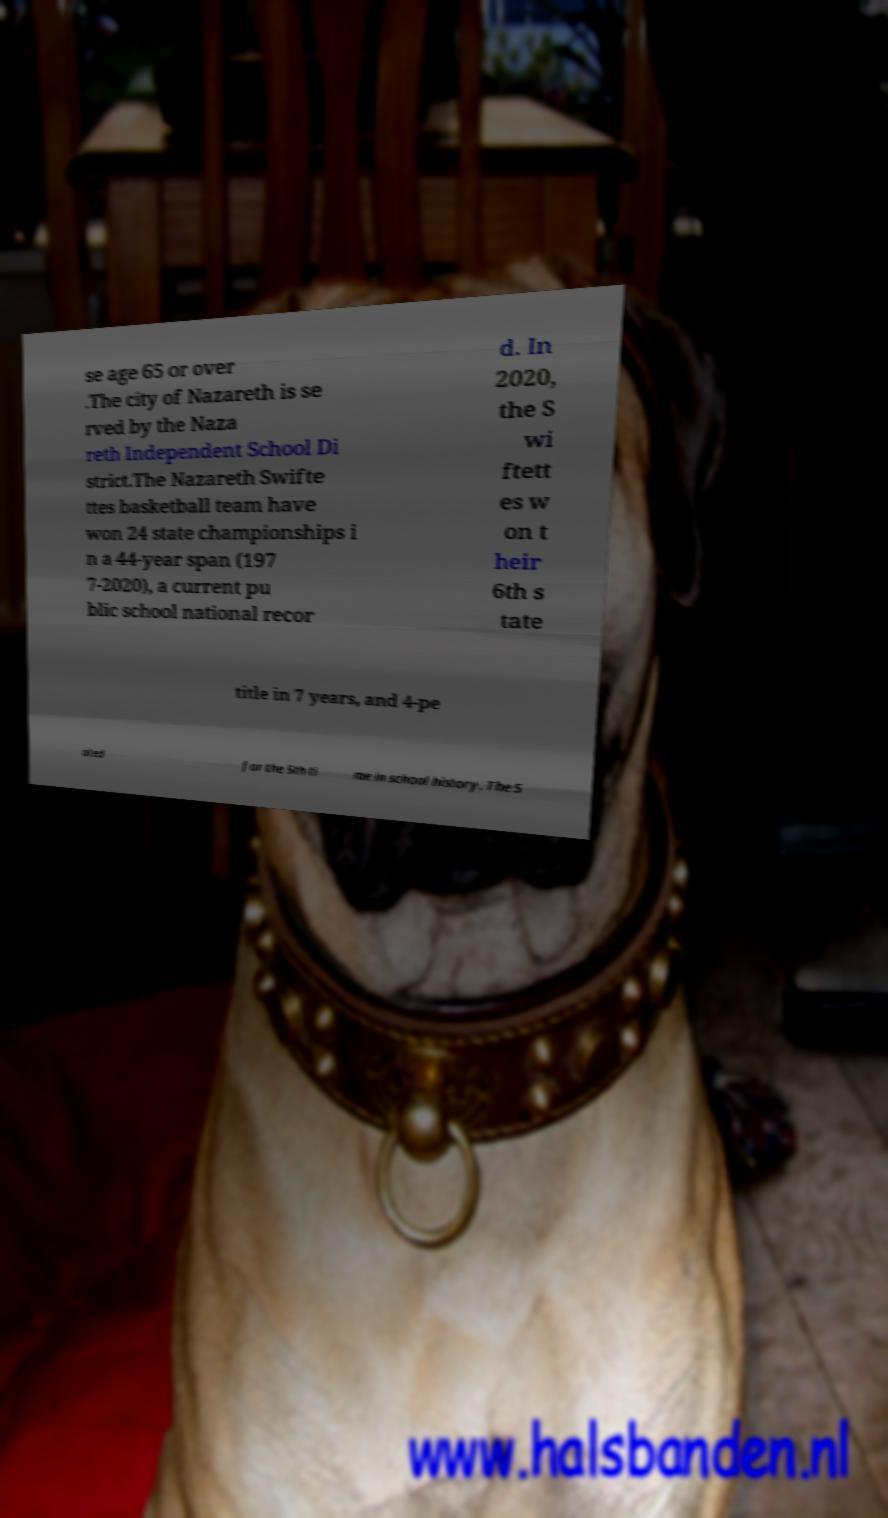Could you extract and type out the text from this image? se age 65 or over .The city of Nazareth is se rved by the Naza reth Independent School Di strict.The Nazareth Swifte ttes basketball team have won 24 state championships i n a 44-year span (197 7-2020), a current pu blic school national recor d. In 2020, the S wi ftett es w on t heir 6th s tate title in 7 years, and 4-pe ated for the 5th ti me in school history. The S 